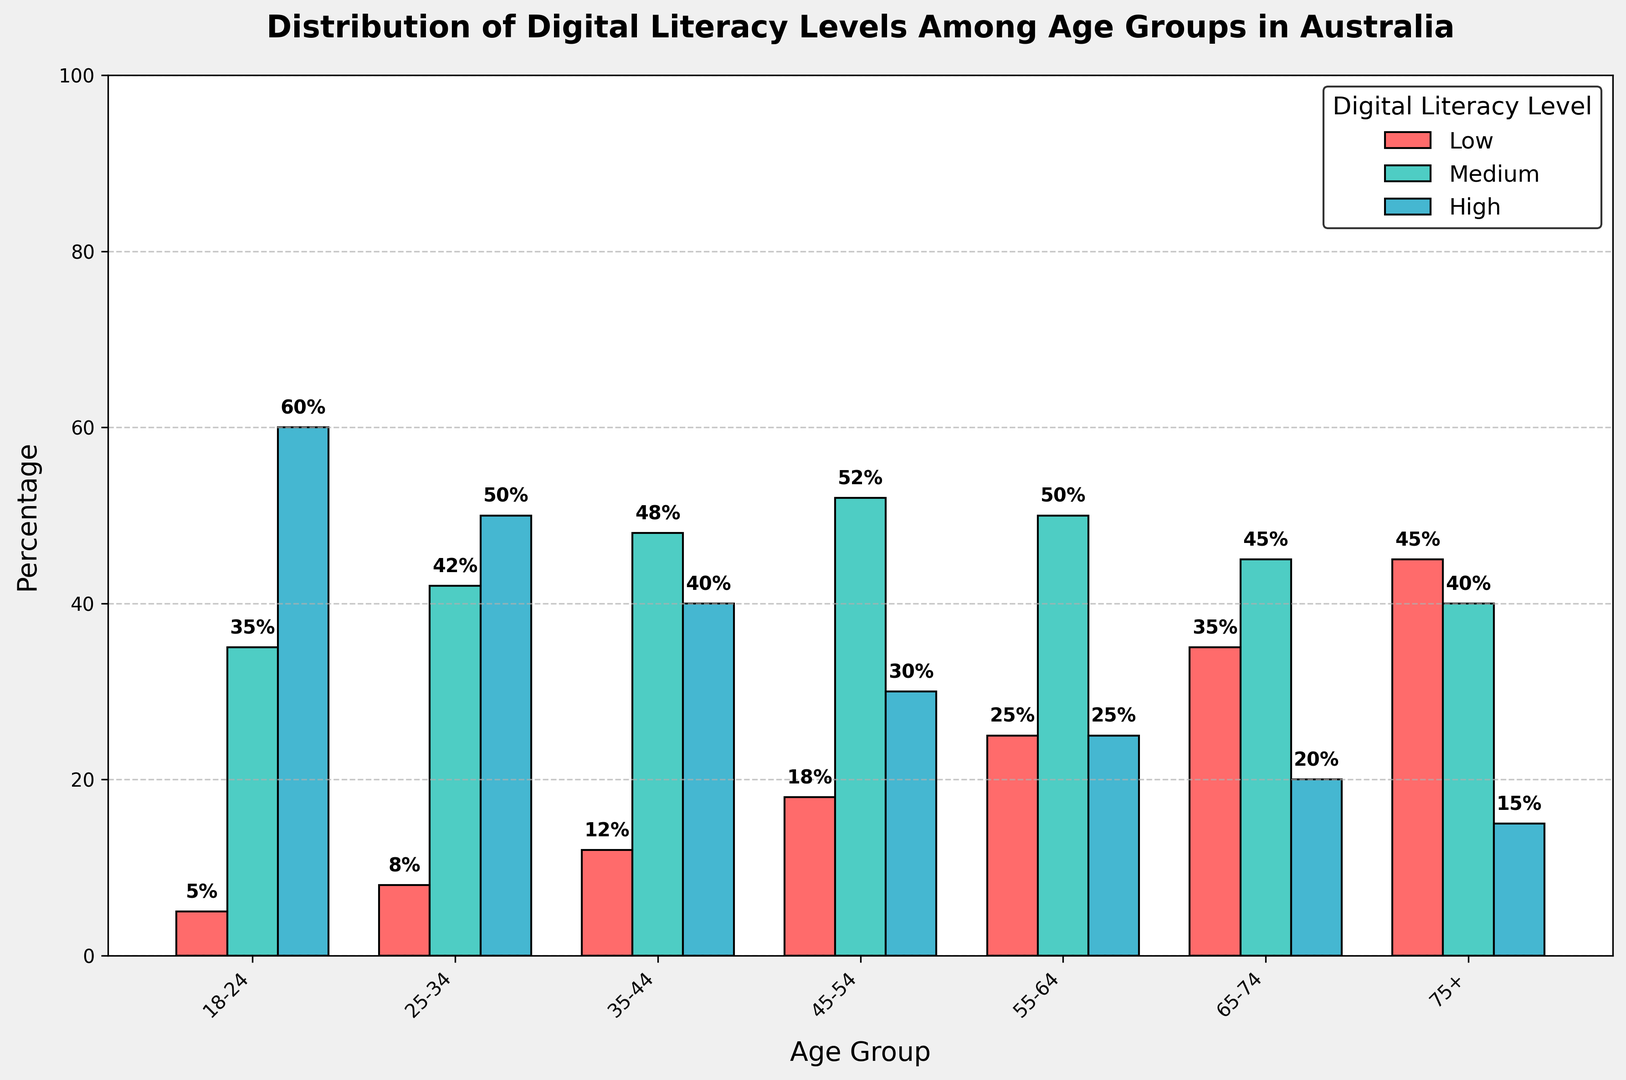Which age group has the highest percentage of low digital literacy? To find the age group with the highest low digital literacy, we compare the percentages: 18-24 (5%), 25-34 (8%), 35-44 (12%), 45-54 (18%), 55-64 (25%), 65-74 (35%), 75+ (45%). The highest percentage is 45%, which corresponds to the 75+ age group
Answer: 75+ What is the difference in high digital literacy between the 18-24 and 65-74 age groups? To determine the difference, we subtract the high digital literacy percentage of the 65-74 age group (20%) from that of the 18-24 age group (60%): 60% - 20% = 40%
Answer: 40% How does the medium digital literacy of the 35-44 age group compare to that of the 55-64 age group? Compare the percentages: 48% (35-44) vs. 50% (55-64). The medium digital literacy of the 35-44 age group is 2% lower than that of the 55-64 age group
Answer: 2% lower Which age group has an equal percentage for medium and high digital literacy, and what is that percentage? We check the age groups for any equal values. The 55-64 age group has 50% for both medium and high digital literacy
Answer: 55-64, 50% Summing the percentages, what is the total digital literacy (low + medium + high) for the 25-34 age group, and does it sum to 100%? Add the percentages: 8% (low) + 42% (medium) + 50% (high) = 100%, which confirms the total digital literacy sums to 100%
Answer: 100%, yes In which age group does the medium digital literacy exceed low digital literacy by at least 30%? We identify the age groups where medium - low ≥ 30%: For 18-24 (35% - 5% = 30%), for 25-34 (42% - 8% = 34%), for 35-44 (48% - 12% = 36%), for 45-54 (52% - 18% = 34%), and for 65-74 (45% - 35% = 10%), only the first four age groups meet this criterion
Answer: 18-24, 25-34, 35-44, 45-54 What is the cumulative percentage of medium and high digital literacy for the 75+ age group? Sum the medium (40%) and high (15%) literacy rates: 40% + 15% = 55%
Answer: 55% Which literacy level (low, medium, or high) has the widest range across all age groups, and what is the range? The range is calculated by subtracting the lowest percentage from the highest for each level. For low: 45% - 5% = 40%; for medium: 52% - 35% = 17%; for high: 60% - 15% = 45%. The highest range is in high digital literacy
Answer: High, 45% What is the ratio of high digital literacy between the 18-24 and 75+ age groups? Divide the high digital literacy percentage of the 18-24 age group by the 75+ age group: 60% / 15% = 4
Answer: 4 to 1 Identify the dominant (highest percentage) digital literacy level for the 45-54 age group Compare the percentages: Low (18%), Medium (52%), High (30%). The medium digital literacy is the highest at 52%
Answer: Medium, 52% 